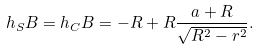Convert formula to latex. <formula><loc_0><loc_0><loc_500><loc_500>h _ { S } B = h _ { C } B & = - R + R \frac { a + R } { \sqrt { R ^ { 2 } - r ^ { 2 } } } .</formula> 